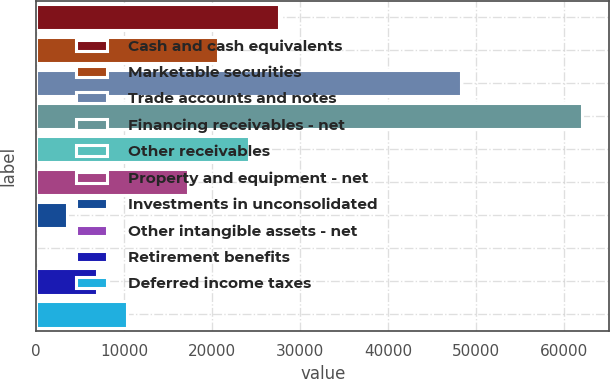Convert chart. <chart><loc_0><loc_0><loc_500><loc_500><bar_chart><fcel>Cash and cash equivalents<fcel>Marketable securities<fcel>Trade accounts and notes<fcel>Financing receivables - net<fcel>Other receivables<fcel>Property and equipment - net<fcel>Investments in unconsolidated<fcel>Other intangible assets - net<fcel>Retirement benefits<fcel>Deferred income taxes<nl><fcel>27597.2<fcel>20698.9<fcel>48292.1<fcel>62088.7<fcel>24148<fcel>17249.8<fcel>3453.15<fcel>4<fcel>6902.3<fcel>10351.5<nl></chart> 